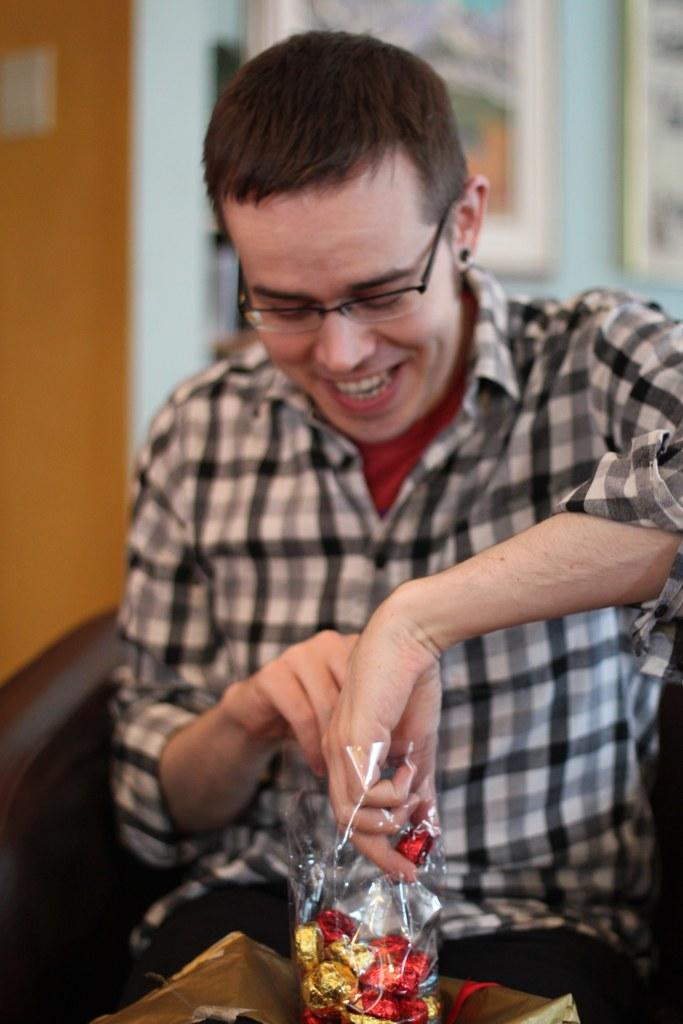What is the man in the image doing? The man is sitting in the image. What is the man holding in the image? The man is holding a cover containing chocolates. What can be seen in the background of the image? There is a wall in the background of the image. What is placed on the wall in the background? There are frames placed on the wall in the background. What type of collar can be seen on the man in the image? There is no collar visible on the man in the image. What is the man trying to find in the image? The image does not provide information about the man trying to find anything. 